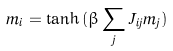<formula> <loc_0><loc_0><loc_500><loc_500>m _ { i } = \tanh { ( { \beta } \sum _ { j } J _ { i j } m _ { j } ) }</formula> 